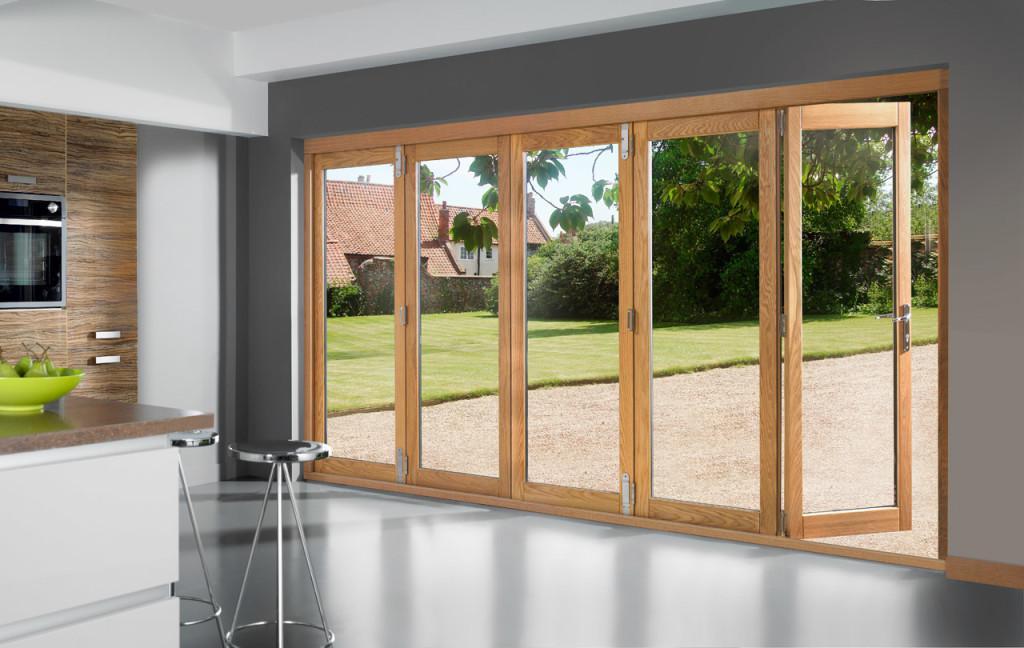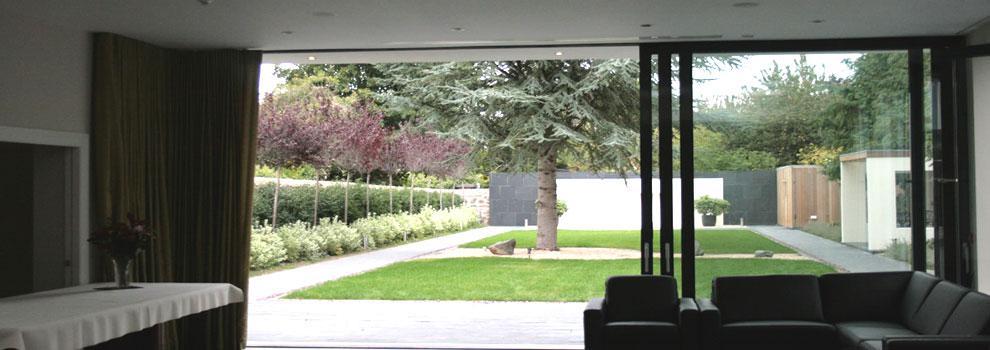The first image is the image on the left, the second image is the image on the right. Evaluate the accuracy of this statement regarding the images: "The doors in the image on the right open to a grassy area.". Is it true? Answer yes or no. Yes. The first image is the image on the left, the second image is the image on the right. Assess this claim about the two images: "An image shows a sliding door unit providing an unobstructed view that is at least as wide as it is tall.". Correct or not? Answer yes or no. Yes. 